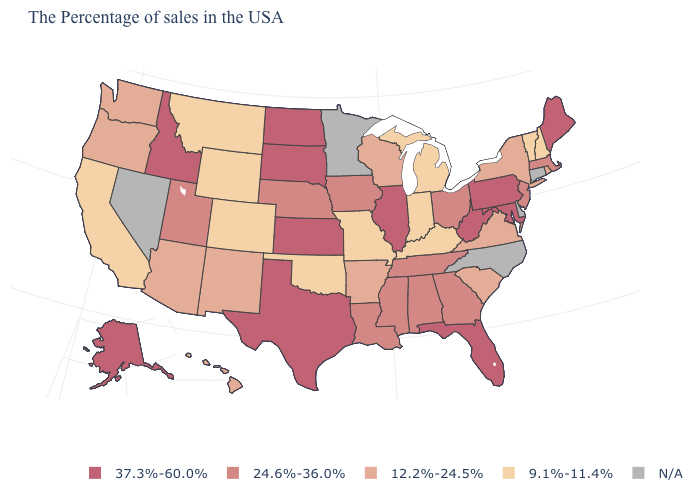Is the legend a continuous bar?
Write a very short answer. No. Which states have the lowest value in the MidWest?
Be succinct. Michigan, Indiana, Missouri. What is the value of New Hampshire?
Be succinct. 9.1%-11.4%. How many symbols are there in the legend?
Answer briefly. 5. What is the value of Nebraska?
Short answer required. 24.6%-36.0%. Name the states that have a value in the range 37.3%-60.0%?
Concise answer only. Maine, Maryland, Pennsylvania, West Virginia, Florida, Illinois, Kansas, Texas, South Dakota, North Dakota, Idaho, Alaska. Name the states that have a value in the range N/A?
Short answer required. Connecticut, Delaware, North Carolina, Minnesota, Nevada. Among the states that border Connecticut , does Rhode Island have the lowest value?
Write a very short answer. Yes. Which states have the highest value in the USA?
Give a very brief answer. Maine, Maryland, Pennsylvania, West Virginia, Florida, Illinois, Kansas, Texas, South Dakota, North Dakota, Idaho, Alaska. How many symbols are there in the legend?
Write a very short answer. 5. Name the states that have a value in the range 24.6%-36.0%?
Keep it brief. Massachusetts, New Jersey, Ohio, Georgia, Alabama, Tennessee, Mississippi, Louisiana, Iowa, Nebraska, Utah. What is the value of Indiana?
Write a very short answer. 9.1%-11.4%. What is the value of Missouri?
Write a very short answer. 9.1%-11.4%. 